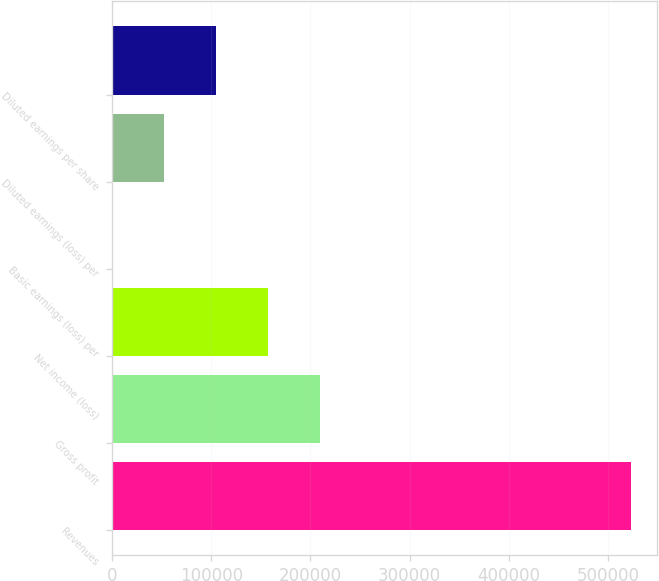<chart> <loc_0><loc_0><loc_500><loc_500><bar_chart><fcel>Revenues<fcel>Gross profit<fcel>Net income (loss)<fcel>Basic earnings (loss) per<fcel>Diluted earnings (loss) per<fcel>Diluted earnings per share<nl><fcel>523340<fcel>209336<fcel>157002<fcel>0.11<fcel>52334.1<fcel>104668<nl></chart> 